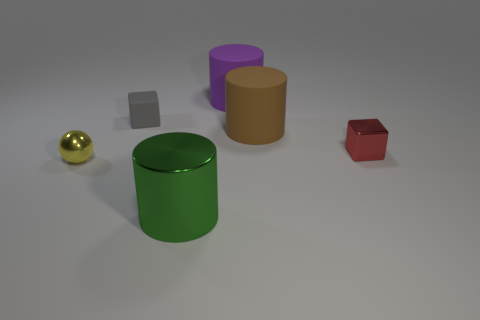What number of balls are purple things or red metallic things?
Keep it short and to the point. 0. Is the shape of the purple object the same as the big green metallic object?
Provide a succinct answer. Yes. What size is the rubber thing that is behind the tiny rubber object?
Make the answer very short. Large. Are there any big cylinders of the same color as the sphere?
Your response must be concise. No. Do the block that is left of the brown cylinder and the red shiny thing have the same size?
Your answer should be compact. Yes. What color is the small matte object?
Your response must be concise. Gray. There is a cube that is behind the tiny thing on the right side of the green metallic object; what is its color?
Keep it short and to the point. Gray. Is there a cyan ball made of the same material as the red block?
Offer a very short reply. No. There is a large cylinder in front of the metal thing to the right of the large green cylinder; what is it made of?
Provide a succinct answer. Metal. What number of yellow metal objects have the same shape as the gray matte object?
Ensure brevity in your answer.  0. 